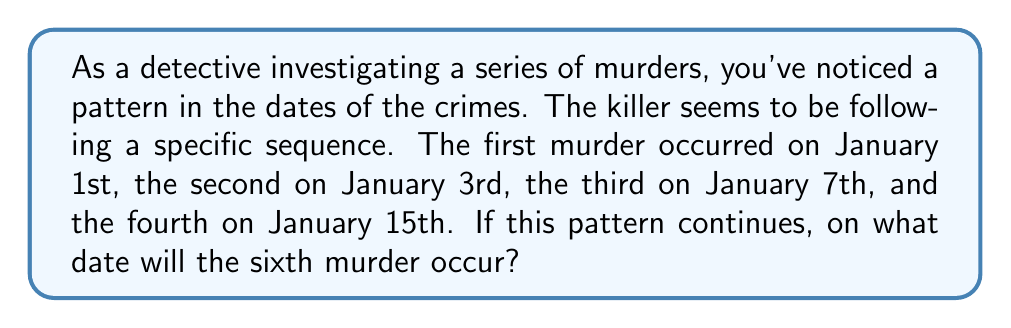Show me your answer to this math problem. Let's approach this step-by-step:

1) First, let's look at the sequence of dates:
   Jan 1, Jan 3, Jan 7, Jan 15

2) To find the pattern, we need to look at the number of days between each murder:
   - Between 1st and 2nd: 3 - 1 = 2 days
   - Between 2nd and 3rd: 7 - 3 = 4 days
   - Between 3rd and 4th: 15 - 7 = 8 days

3) We can see that the number of days between murders is doubling each time:
   2, 4, 8

4) This forms a geometric sequence with a common ratio of 2.

5) We can represent this sequence mathematically as:
   $$a_n = 2^n$$
   where $a_n$ is the number of days after the previous murder, and $n$ starts at 0.

6) So, for the 5th murder (which would be the 4th term in our sequence of days between murders):
   $$a_4 = 2^4 = 16$$ days after January 15th

7) For the 6th murder (5th term in our sequence):
   $$a_5 = 2^5 = 32$$ days after the 5th murder

8) So we need to add:
   16 days (to get to the 5th murder date)
   + 32 days (to get to the 6th murder date)
   = 48 days total from January 15th

9) Counting 48 days from January 15th brings us to March 3rd.
Answer: March 3rd 